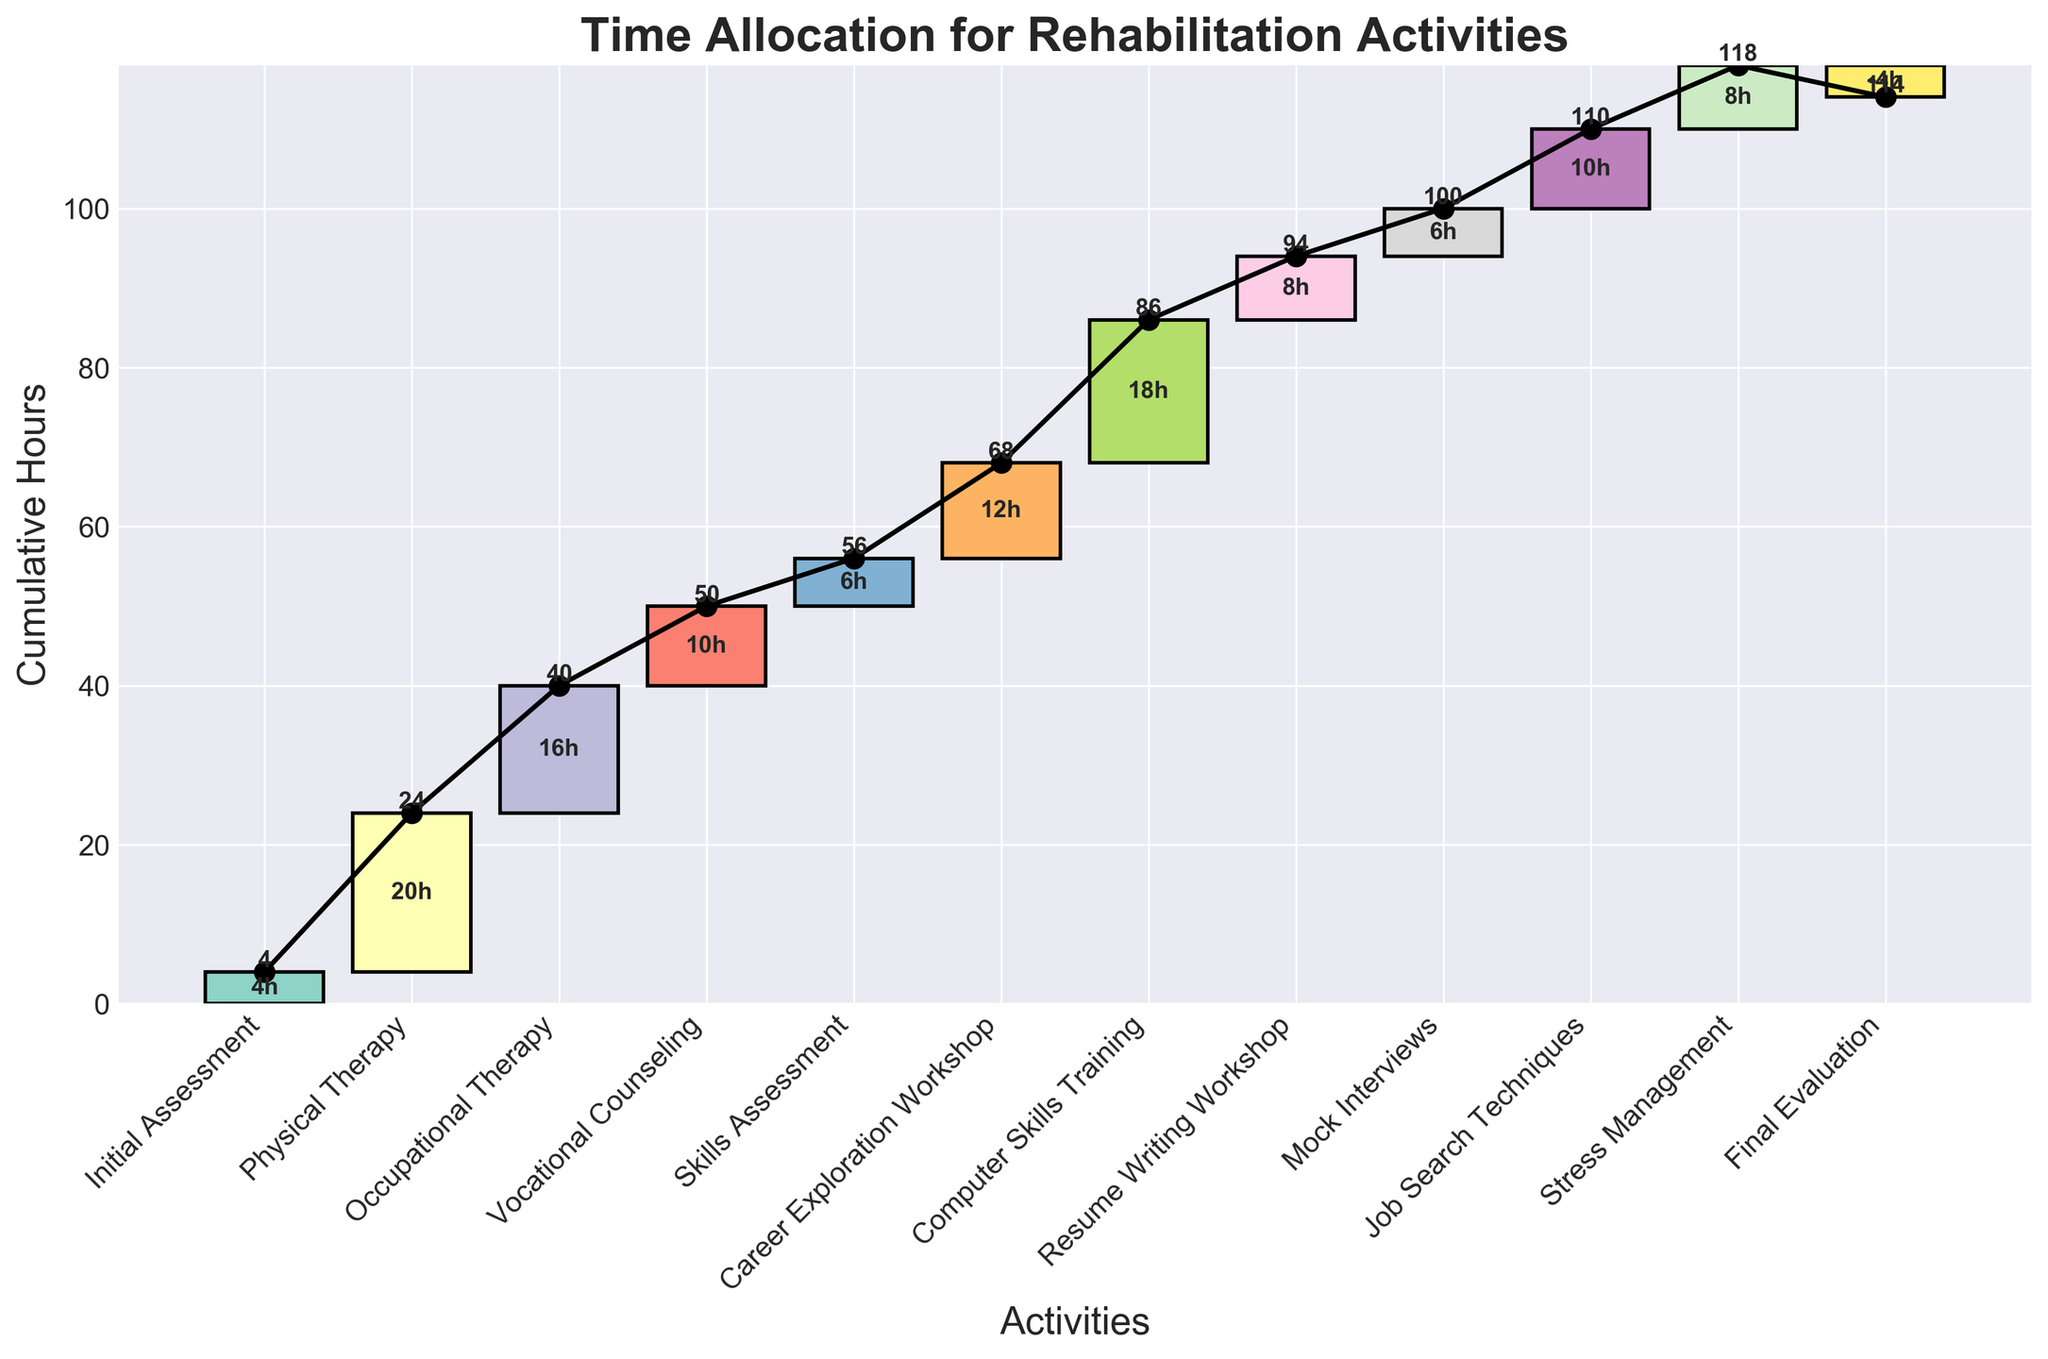What is the title of the chart? The title of the chart is typically shown at the top and provides an overview of what the chart is about. In this case, it is clearly labeled in the code.
Answer: Time Allocation for Rehabilitation Activities How many activities are listed in the chart? You count the number of unique entries along the x-axis to determine the total number of activities.
Answer: 12 Which activity contributes the most hours to the rehabilitation program? By looking at the heights of the bars or the values indicated on the bars, you identify the activity with the highest numerical value.
Answer: Physical Therapy What is the cumulative number of hours after the Vocational Counseling activity? Sum the hours from the Initial Assessment, Physical Therapy, Occupational Therapy, and Vocational Counseling activities to find the cumulative total up to that point. 4 (Initial Assessment) + 20 (Physical Therapy) + 16 (Occupational Therapy) + 10 (Vocational Counseling) = 50 hours
Answer: 50 hours How does the number of hours allocated to Stress Management compare to Resume Writing Workshop? Check the values on the bars for both Stress Management and Resume Writing Workshop and compare them. Stress Management has 8 hours, and Resume Writing Workshop also has 8 hours.
Answer: They are equal Which activities have the shortest and longest duration? By comparing all the bar heights or the values indicated, identify the shortest and longest bars. The shortest single activity is Final Evaluation (though it's negative, it has the minimum absolute duration). The longest is Physical Therapy.
Answer: Shortest: Final Evaluation, Longest: Physical Therapy What is the cumulative total of hours at the end of the program? Add up all the hours from Initial Assessment to Final Evaluation to determine the total hours. The sum of all activities minus the Final Evaluation: 4 + 20 + 16 + 10 + 6 + 12 + 18 + 8 + 6 + 10 + 8 - 4 = 114 hours
Answer: 114 hours Calculate the average number of hours allocated per activity. Sum all the hours and divide by the number of activities: (4 + 20 + 16 + 10 + 6 + 12 + 18 + 8 + 6 + 10 + 8 - 4)/12 = 114/12 = 9.5 hours
Answer: 9.5 hours What is the overall trend throughout the program based on the cumulative hours line? The cumulative hours line generally increases rapidly then tapers off towards the end, indicating a steady initial increase in allocated hours and then a more even distribution.
Answer: Steady increase initially, then more even What is the difference in cumulative hours between Skills Assessment and Career Exploration Workshop? Sum the hours up to and including Skills Assessment and Career Exploration Workshop, then find the difference. Skills Assessment cumulative: 4+20+16+10+6 = 56 hours; Career Exploration Workshop cumulative: 56+12 = 68 hours; Difference = 68-56 = 12 hours
Answer: 12 hours 